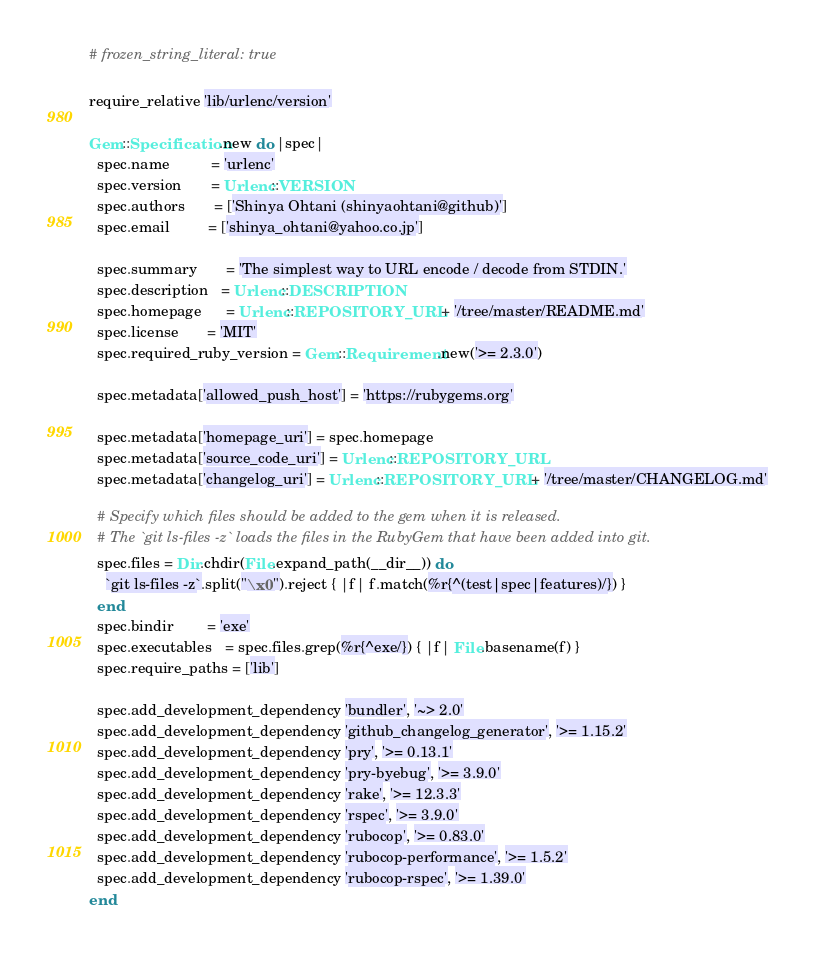<code> <loc_0><loc_0><loc_500><loc_500><_Ruby_># frozen_string_literal: true

require_relative 'lib/urlenc/version'

Gem::Specification.new do |spec|
  spec.name          = 'urlenc'
  spec.version       = Urlenc::VERSION
  spec.authors       = ['Shinya Ohtani (shinyaohtani@github)']
  spec.email         = ['shinya_ohtani@yahoo.co.jp']

  spec.summary       = 'The simplest way to URL encode / decode from STDIN.'
  spec.description   = Urlenc::DESCRIPTION
  spec.homepage      = Urlenc::REPOSITORY_URL + '/tree/master/README.md'
  spec.license       = 'MIT'
  spec.required_ruby_version = Gem::Requirement.new('>= 2.3.0')

  spec.metadata['allowed_push_host'] = 'https://rubygems.org'

  spec.metadata['homepage_uri'] = spec.homepage
  spec.metadata['source_code_uri'] = Urlenc::REPOSITORY_URL
  spec.metadata['changelog_uri'] = Urlenc::REPOSITORY_URL + '/tree/master/CHANGELOG.md'

  # Specify which files should be added to the gem when it is released.
  # The `git ls-files -z` loads the files in the RubyGem that have been added into git.
  spec.files = Dir.chdir(File.expand_path(__dir__)) do
    `git ls-files -z`.split("\x0").reject { |f| f.match(%r{^(test|spec|features)/}) }
  end
  spec.bindir        = 'exe'
  spec.executables   = spec.files.grep(%r{^exe/}) { |f| File.basename(f) }
  spec.require_paths = ['lib']

  spec.add_development_dependency 'bundler', '~> 2.0'
  spec.add_development_dependency 'github_changelog_generator', '>= 1.15.2'
  spec.add_development_dependency 'pry', '>= 0.13.1'
  spec.add_development_dependency 'pry-byebug', '>= 3.9.0'
  spec.add_development_dependency 'rake', '>= 12.3.3'
  spec.add_development_dependency 'rspec', '>= 3.9.0'
  spec.add_development_dependency 'rubocop', '>= 0.83.0'
  spec.add_development_dependency 'rubocop-performance', '>= 1.5.2'
  spec.add_development_dependency 'rubocop-rspec', '>= 1.39.0'
end
</code> 